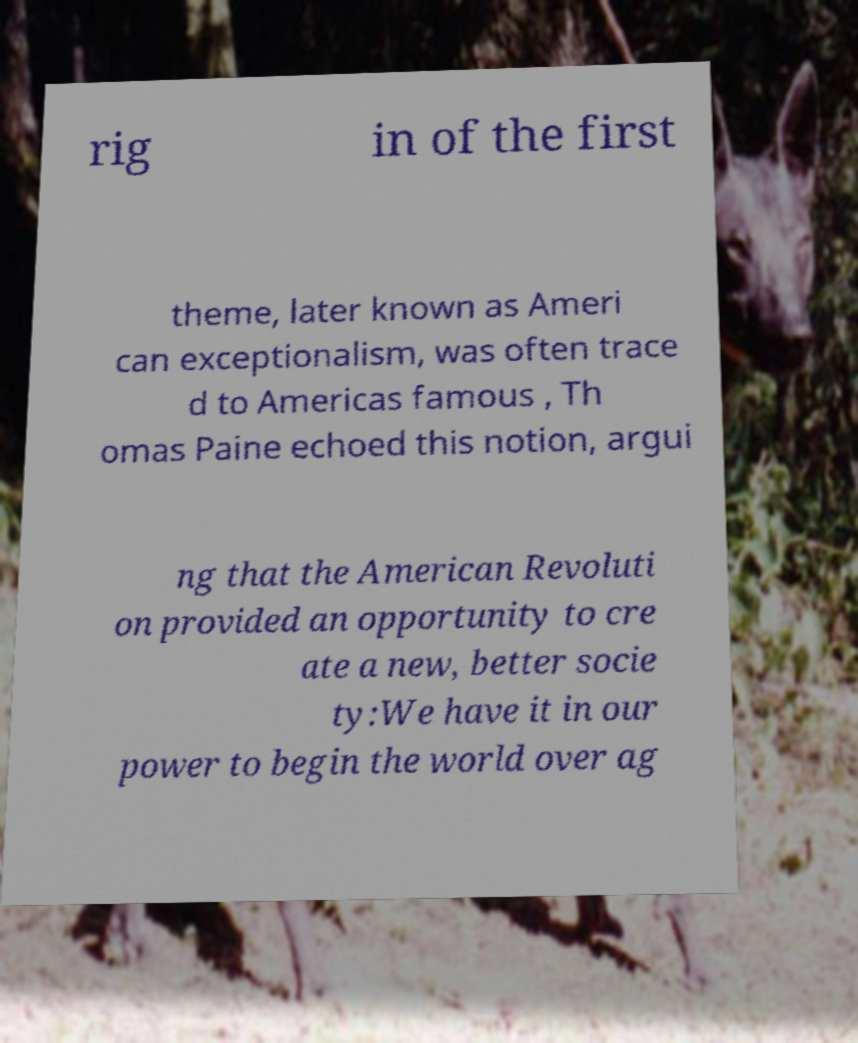What messages or text are displayed in this image? I need them in a readable, typed format. rig in of the first theme, later known as Ameri can exceptionalism, was often trace d to Americas famous , Th omas Paine echoed this notion, argui ng that the American Revoluti on provided an opportunity to cre ate a new, better socie ty:We have it in our power to begin the world over ag 